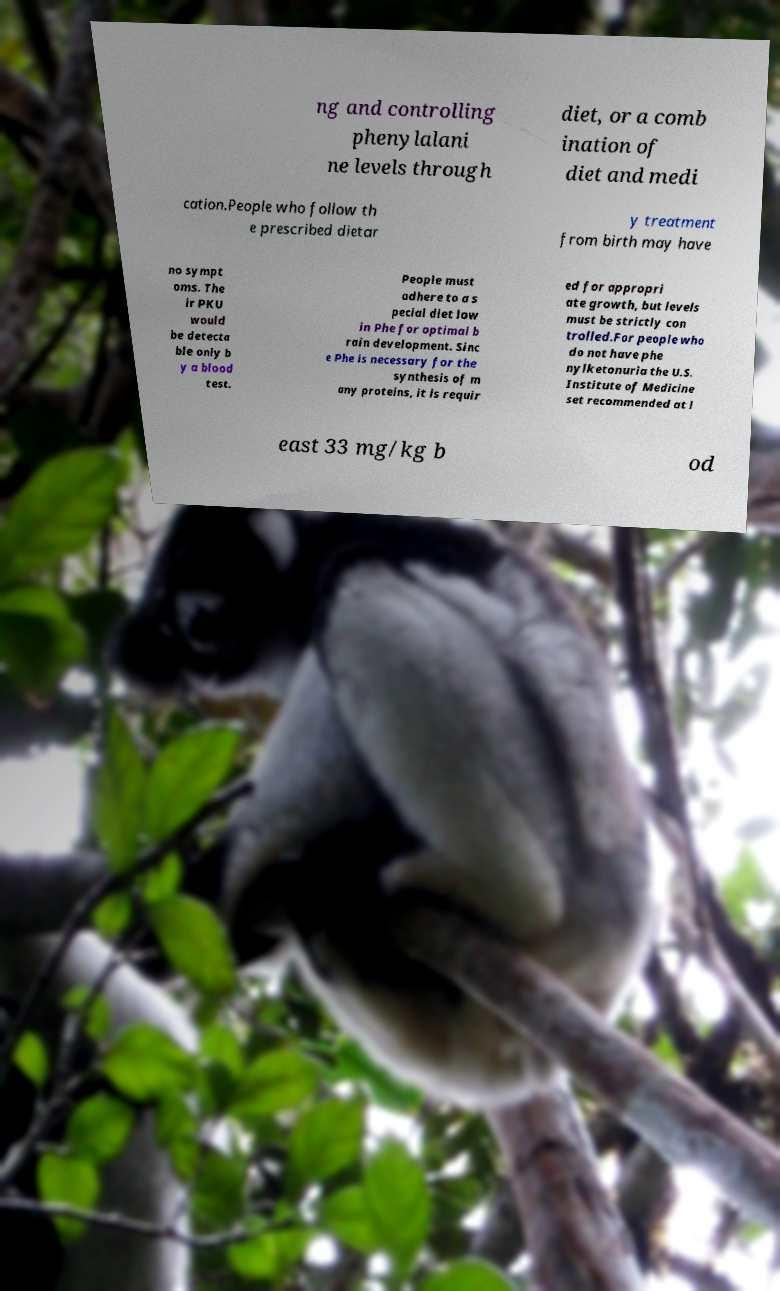Could you assist in decoding the text presented in this image and type it out clearly? ng and controlling phenylalani ne levels through diet, or a comb ination of diet and medi cation.People who follow th e prescribed dietar y treatment from birth may have no sympt oms. The ir PKU would be detecta ble only b y a blood test. People must adhere to a s pecial diet low in Phe for optimal b rain development. Sinc e Phe is necessary for the synthesis of m any proteins, it is requir ed for appropri ate growth, but levels must be strictly con trolled.For people who do not have phe nylketonuria the U.S. Institute of Medicine set recommended at l east 33 mg/kg b od 